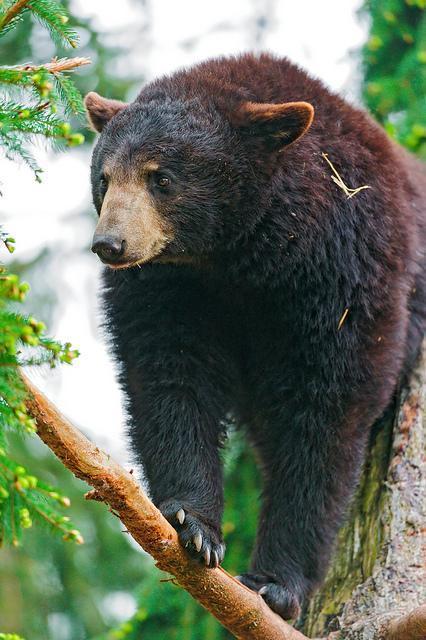How many of the train's visible cars have yellow on them>?
Give a very brief answer. 0. 